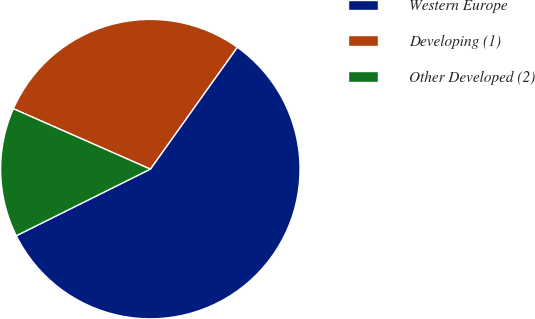Convert chart. <chart><loc_0><loc_0><loc_500><loc_500><pie_chart><fcel>Western Europe<fcel>Developing (1)<fcel>Other Developed (2)<nl><fcel>57.8%<fcel>28.25%<fcel>13.95%<nl></chart> 